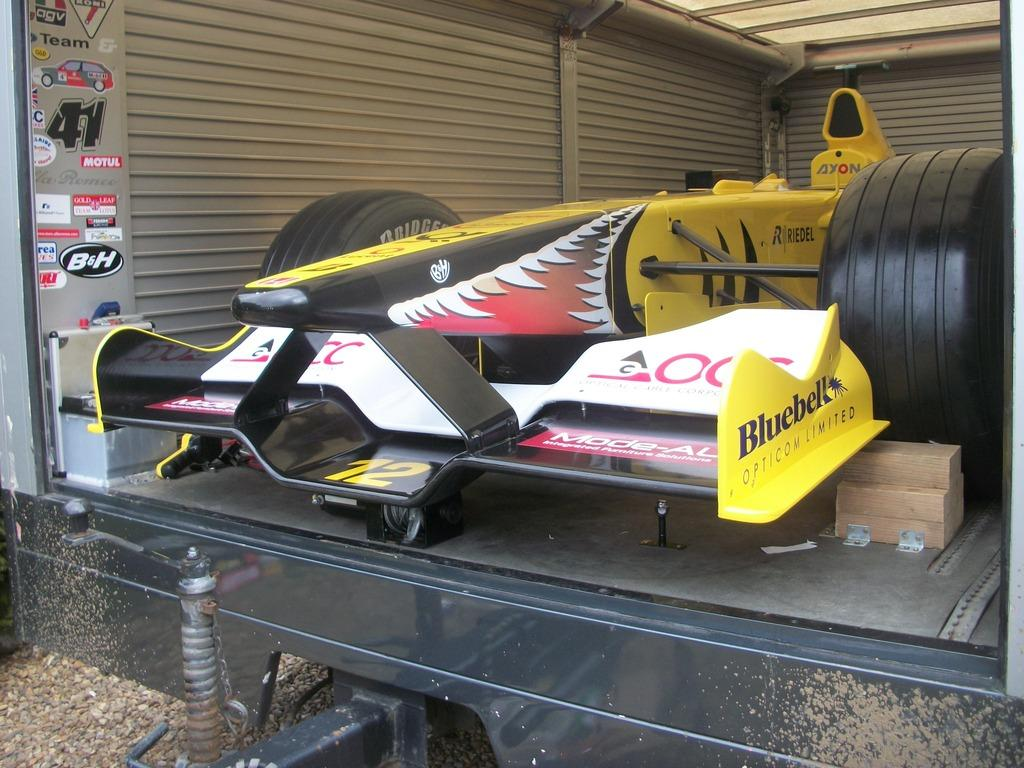What is inside the container in the image? There is a vehicle in a container in the image. What type of decorations or advertisements can be seen in the image? There are posters visible in the image. What type of structure is present in the image? There is a wall in the image. What part of the structure is visible in the image? The roof is visible in the image. What is the surface on which the structure is built? The ground is visible in the image. What type of material is present on the ground? There are stones in the image. What type of container is present in the image? There is a wooden box in the image. What type of canvas is being used to create a painting in the image? There is no canvas or painting present in the image. What type of work is being done in the image? The image does not depict any work or labor being performed. What is the second roof visible in the image? There is only one roof visible in the image, which is part of the structure containing the vehicle. 